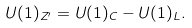Convert formula to latex. <formula><loc_0><loc_0><loc_500><loc_500>U ( 1 ) _ { Z ^ { \prime } } = U ( 1 ) _ { C } - U ( 1 ) _ { L } .</formula> 